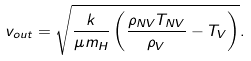<formula> <loc_0><loc_0><loc_500><loc_500>v _ { o u t } = \sqrt { \frac { k } { \mu m _ { H } } \left ( \frac { \rho _ { N V } T _ { N V } } { \rho _ { V } } - T _ { V } \right ) } .</formula> 